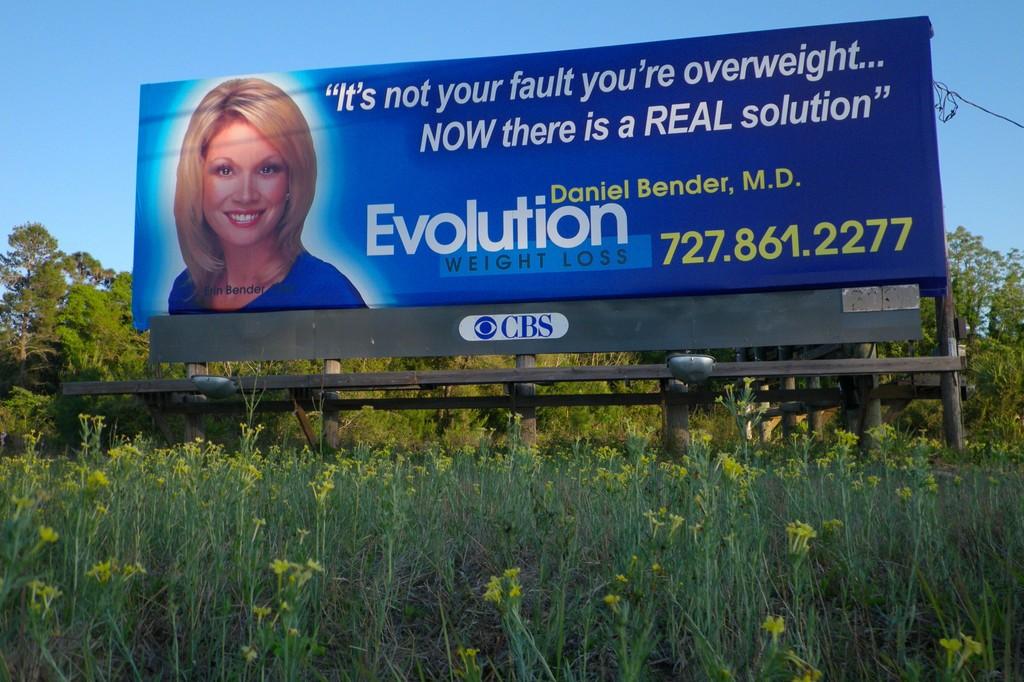What is the phone number listed?
Offer a terse response. 727.861.2277. 